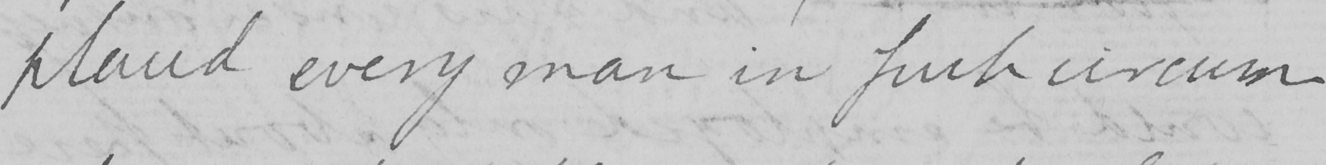What does this handwritten line say? placed every man in such circum- 